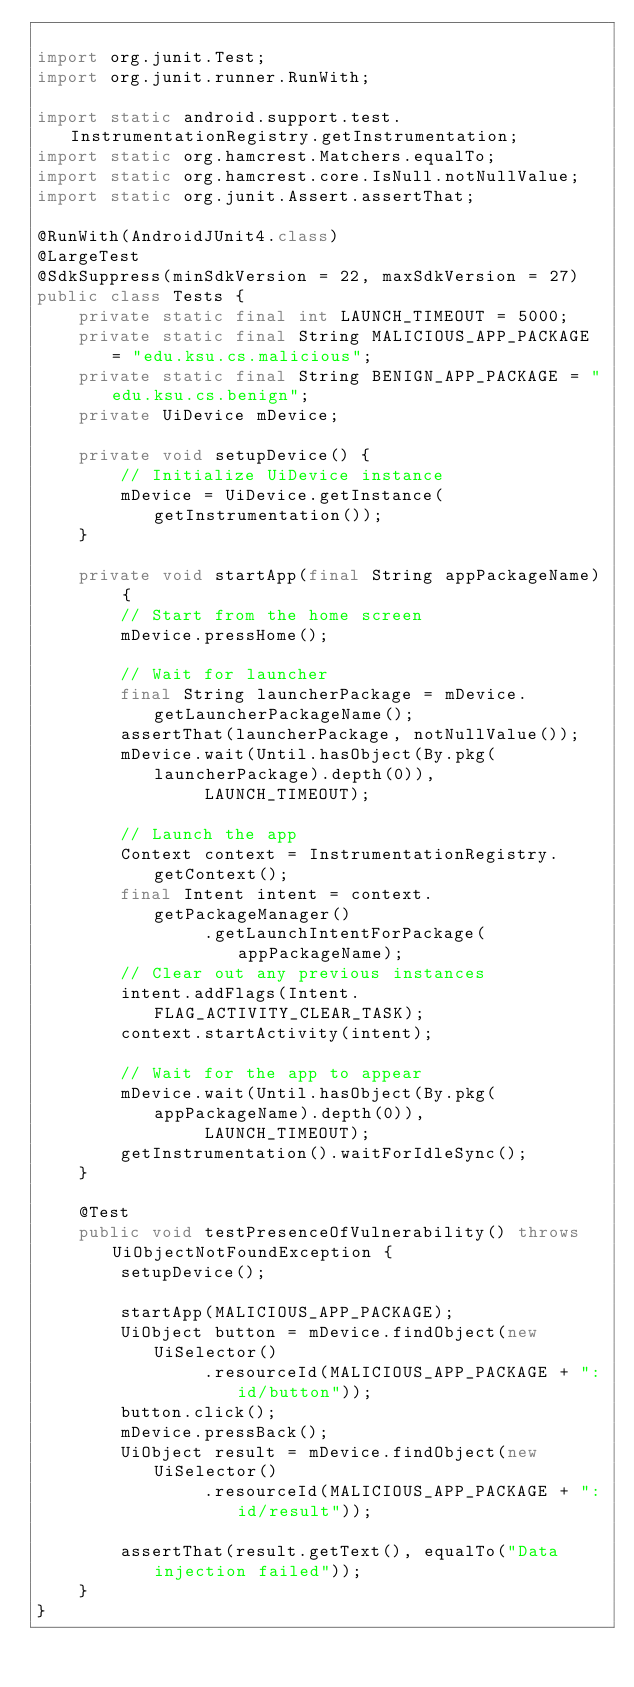Convert code to text. <code><loc_0><loc_0><loc_500><loc_500><_Java_>
import org.junit.Test;
import org.junit.runner.RunWith;

import static android.support.test.InstrumentationRegistry.getInstrumentation;
import static org.hamcrest.Matchers.equalTo;
import static org.hamcrest.core.IsNull.notNullValue;
import static org.junit.Assert.assertThat;

@RunWith(AndroidJUnit4.class)
@LargeTest
@SdkSuppress(minSdkVersion = 22, maxSdkVersion = 27)
public class Tests {
    private static final int LAUNCH_TIMEOUT = 5000;
    private static final String MALICIOUS_APP_PACKAGE = "edu.ksu.cs.malicious";
    private static final String BENIGN_APP_PACKAGE = "edu.ksu.cs.benign";
    private UiDevice mDevice;

    private void setupDevice() {
        // Initialize UiDevice instance
        mDevice = UiDevice.getInstance(getInstrumentation());
    }

    private void startApp(final String appPackageName) {
        // Start from the home screen
        mDevice.pressHome();

        // Wait for launcher
        final String launcherPackage = mDevice.getLauncherPackageName();
        assertThat(launcherPackage, notNullValue());
        mDevice.wait(Until.hasObject(By.pkg(launcherPackage).depth(0)),
                LAUNCH_TIMEOUT);

        // Launch the app
        Context context = InstrumentationRegistry.getContext();
        final Intent intent = context.getPackageManager()
                .getLaunchIntentForPackage(appPackageName);
        // Clear out any previous instances
        intent.addFlags(Intent.FLAG_ACTIVITY_CLEAR_TASK);
        context.startActivity(intent);

        // Wait for the app to appear
        mDevice.wait(Until.hasObject(By.pkg(appPackageName).depth(0)),
                LAUNCH_TIMEOUT);
        getInstrumentation().waitForIdleSync();
    }

    @Test
    public void testPresenceOfVulnerability() throws UiObjectNotFoundException {
        setupDevice();

        startApp(MALICIOUS_APP_PACKAGE);
        UiObject button = mDevice.findObject(new UiSelector()
                .resourceId(MALICIOUS_APP_PACKAGE + ":id/button"));
        button.click();
        mDevice.pressBack();
        UiObject result = mDevice.findObject(new UiSelector()
                .resourceId(MALICIOUS_APP_PACKAGE + ":id/result"));

        assertThat(result.getText(), equalTo("Data injection failed"));
    }
}
</code> 